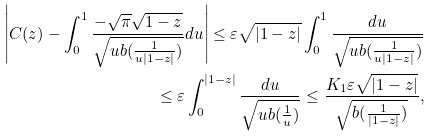<formula> <loc_0><loc_0><loc_500><loc_500>\left | C ( z ) - \int _ { 0 } ^ { 1 } \frac { - \sqrt { \pi } \sqrt { 1 - z } } { \sqrt { u b ( \frac { 1 } { u | 1 - z | } ) } } d u \right | \leq \varepsilon \sqrt { | 1 - z | } \int _ { 0 } ^ { 1 } \frac { d u } { \sqrt { u b ( \frac { 1 } { u | 1 - z | } ) } } \\ \leq \varepsilon \int _ { 0 } ^ { | 1 - z | } \frac { d u } { \sqrt { u b ( \frac { 1 } { u } ) } } \leq \frac { K _ { 1 } \varepsilon \sqrt { | 1 - z | } } { \sqrt { b ( \frac { 1 } { | 1 - z | } ) } } ,</formula> 